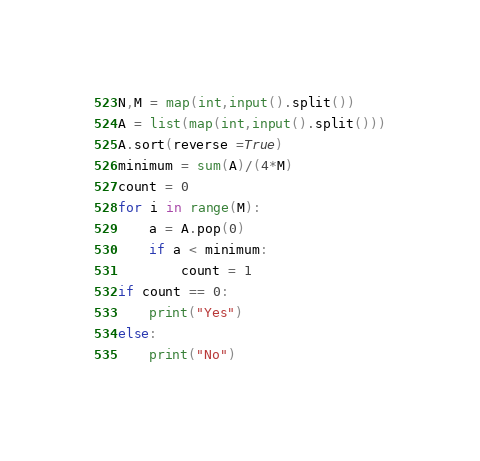Convert code to text. <code><loc_0><loc_0><loc_500><loc_500><_Python_>N,M = map(int,input().split())
A = list(map(int,input().split()))
A.sort(reverse =True)
minimum = sum(A)/(4*M)
count = 0
for i in range(M):
    a = A.pop(0)
    if a < minimum:
        count = 1
if count == 0:
    print("Yes")
else:
    print("No")</code> 